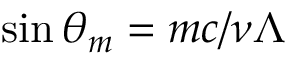Convert formula to latex. <formula><loc_0><loc_0><loc_500><loc_500>\sin \theta _ { m } = m c / \nu \Lambda</formula> 